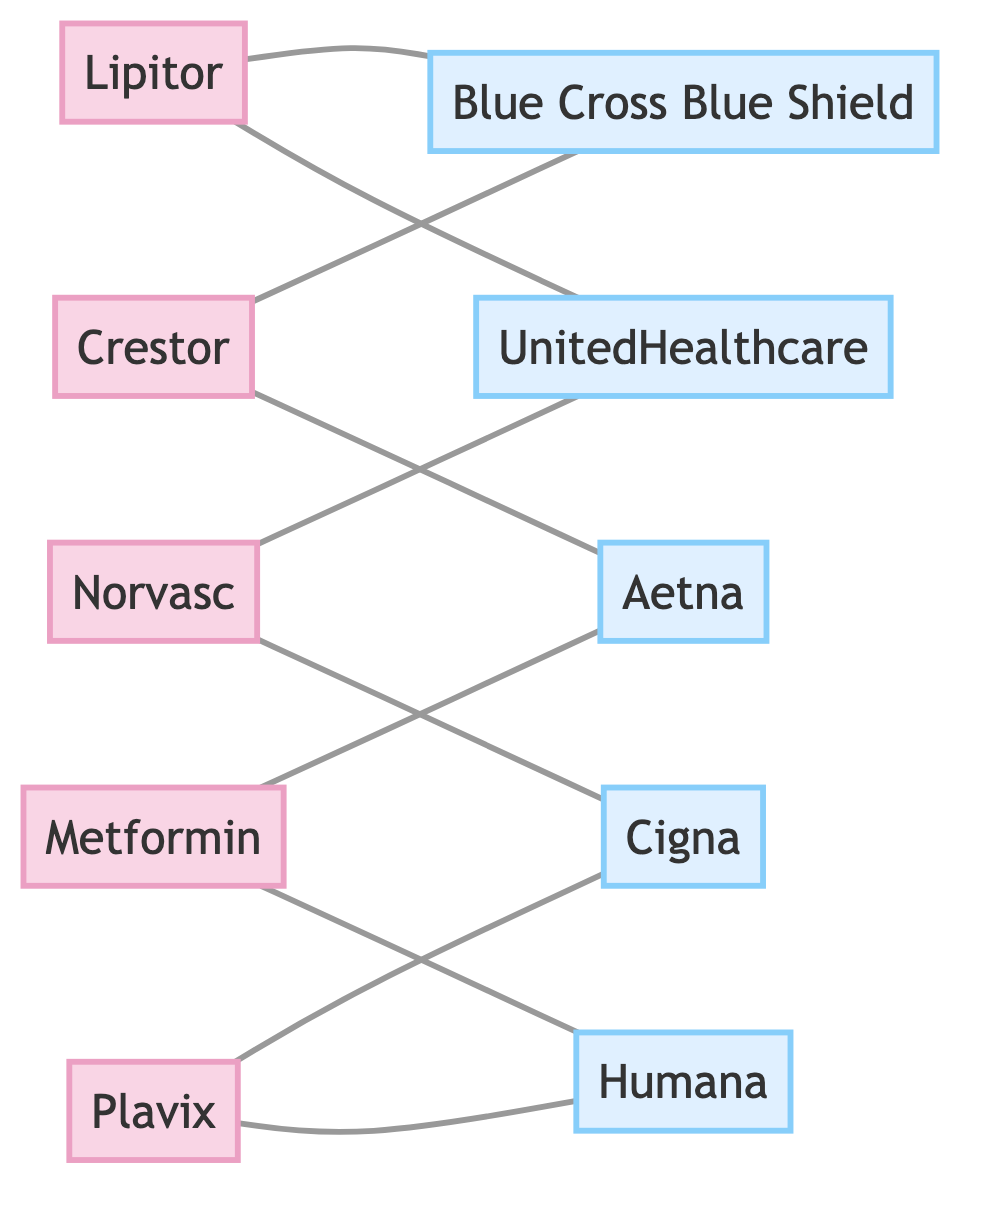What drugs are covered by Blue Cross Blue Shield? To find the drugs covered by Blue Cross Blue Shield, I need to look for edges that connect to the insurance node labeled 'Blue Cross Blue Shield'. The drugs connected to it are Lipitor and Crestor.
Answer: Lipitor, Crestor Which insurance companies cover Plavix? I check the edges connected to the node representing Plavix. It is linked to Cigna and Humana.
Answer: Cigna, Humana How many drugs are covered by Aetna? I identify the edges connecting to Aetna. The drugs that connect to Aetna are Crestor and Metformin. Counting these gives a total of two drugs.
Answer: 2 Which drug is covered by the most insurance companies? I will analyze the connections for each drug. Lipitor is connected to 2 insurance companies, Crestor to 2, Norvasc to 2, Plavix to 2, and Metformin to 2. None exceed 2 connections, making them all equal.
Answer: Lipitor, Crestor, Norvasc, Plavix, Metformin What is the relationship between Metformin and UnitedHealthcare? To determine the relationship, I look for an edge between the node for Metformin and the node for UnitedHealthcare. There is a direct connection, indicating that Metformin is covered by UnitedHealthcare.
Answer: Covered How many total edges are represented in the diagram? The edges in the diagram can be counted. There are 10 edges connecting the drugs and insurance companies.
Answer: 10 Which drug has coverage from Cigna? I need to locate the edges connected to the Cigna node. Plavix and Norvasc are the drugs connected to it.
Answer: Plavix Which drug is shared by both UnitedHealthcare and Aetna? I will check for connections of both UnitedHealthcare and Aetna to see if any drug is linked to both. The only drug that connects to both insurance companies is Metformin.
Answer: Metformin How many insurance companies cover Norvasc? I find the edges from the Norvasc node to see how many insurance companies it connects to. Norvasc connects to UnitedHealthcare and Cigna, totaling 2.
Answer: 2 